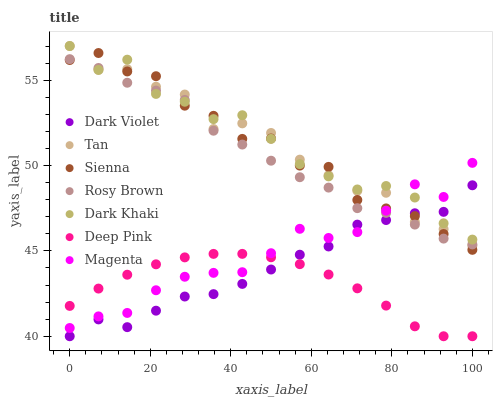Does Deep Pink have the minimum area under the curve?
Answer yes or no. Yes. Does Dark Khaki have the maximum area under the curve?
Answer yes or no. Yes. Does Rosy Brown have the minimum area under the curve?
Answer yes or no. No. Does Rosy Brown have the maximum area under the curve?
Answer yes or no. No. Is Deep Pink the smoothest?
Answer yes or no. Yes. Is Sienna the roughest?
Answer yes or no. Yes. Is Rosy Brown the smoothest?
Answer yes or no. No. Is Rosy Brown the roughest?
Answer yes or no. No. Does Deep Pink have the lowest value?
Answer yes or no. Yes. Does Rosy Brown have the lowest value?
Answer yes or no. No. Does Tan have the highest value?
Answer yes or no. Yes. Does Rosy Brown have the highest value?
Answer yes or no. No. Is Deep Pink less than Dark Khaki?
Answer yes or no. Yes. Is Tan greater than Deep Pink?
Answer yes or no. Yes. Does Rosy Brown intersect Sienna?
Answer yes or no. Yes. Is Rosy Brown less than Sienna?
Answer yes or no. No. Is Rosy Brown greater than Sienna?
Answer yes or no. No. Does Deep Pink intersect Dark Khaki?
Answer yes or no. No. 